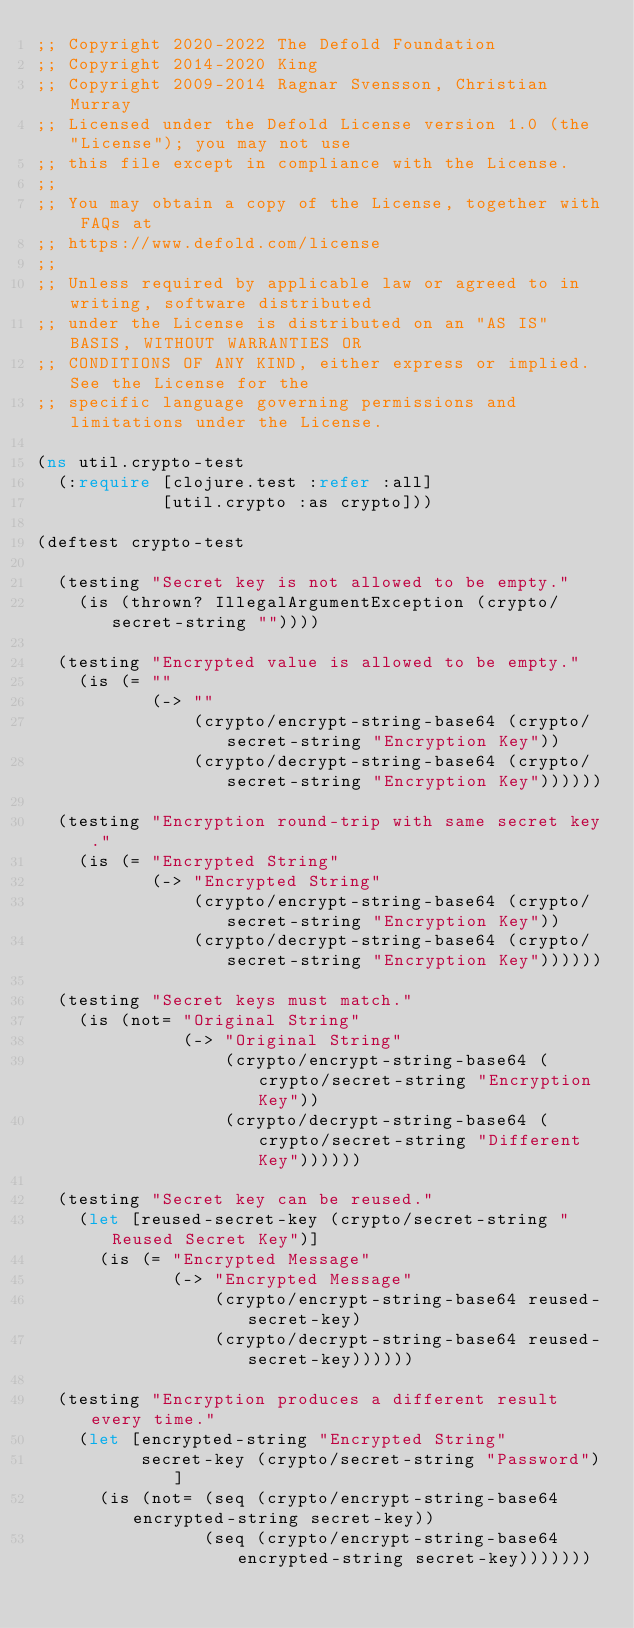Convert code to text. <code><loc_0><loc_0><loc_500><loc_500><_Clojure_>;; Copyright 2020-2022 The Defold Foundation
;; Copyright 2014-2020 King
;; Copyright 2009-2014 Ragnar Svensson, Christian Murray
;; Licensed under the Defold License version 1.0 (the "License"); you may not use
;; this file except in compliance with the License.
;; 
;; You may obtain a copy of the License, together with FAQs at
;; https://www.defold.com/license
;; 
;; Unless required by applicable law or agreed to in writing, software distributed
;; under the License is distributed on an "AS IS" BASIS, WITHOUT WARRANTIES OR
;; CONDITIONS OF ANY KIND, either express or implied. See the License for the
;; specific language governing permissions and limitations under the License.

(ns util.crypto-test
  (:require [clojure.test :refer :all]
            [util.crypto :as crypto]))

(deftest crypto-test

  (testing "Secret key is not allowed to be empty."
    (is (thrown? IllegalArgumentException (crypto/secret-string ""))))

  (testing "Encrypted value is allowed to be empty."
    (is (= ""
           (-> ""
               (crypto/encrypt-string-base64 (crypto/secret-string "Encryption Key"))
               (crypto/decrypt-string-base64 (crypto/secret-string "Encryption Key"))))))

  (testing "Encryption round-trip with same secret key."
    (is (= "Encrypted String"
           (-> "Encrypted String"
               (crypto/encrypt-string-base64 (crypto/secret-string "Encryption Key"))
               (crypto/decrypt-string-base64 (crypto/secret-string "Encryption Key"))))))

  (testing "Secret keys must match."
    (is (not= "Original String"
              (-> "Original String"
                  (crypto/encrypt-string-base64 (crypto/secret-string "Encryption Key"))
                  (crypto/decrypt-string-base64 (crypto/secret-string "Different Key"))))))

  (testing "Secret key can be reused."
    (let [reused-secret-key (crypto/secret-string "Reused Secret Key")]
      (is (= "Encrypted Message"
             (-> "Encrypted Message"
                 (crypto/encrypt-string-base64 reused-secret-key)
                 (crypto/decrypt-string-base64 reused-secret-key))))))

  (testing "Encryption produces a different result every time."
    (let [encrypted-string "Encrypted String"
          secret-key (crypto/secret-string "Password")]
      (is (not= (seq (crypto/encrypt-string-base64 encrypted-string secret-key))
                (seq (crypto/encrypt-string-base64 encrypted-string secret-key)))))))
</code> 